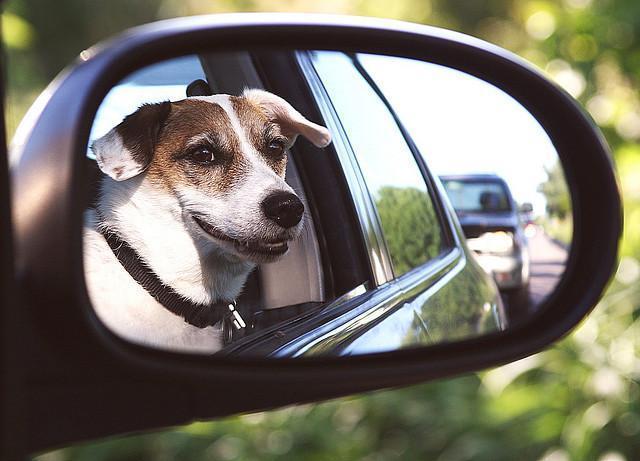How many cars are visible?
Give a very brief answer. 2. 